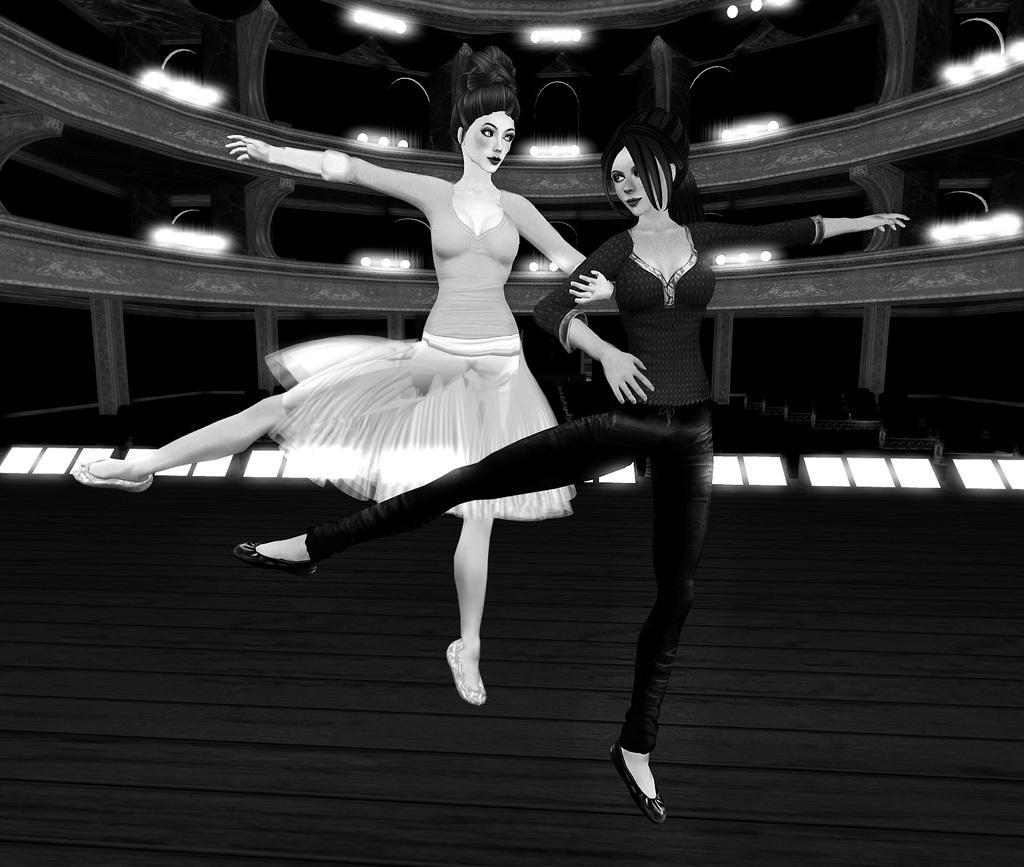How would you summarize this image in a sentence or two? In the picture we can see an animated image of two girls are dancing holding each other hands and behind them we can see the animated stadium building with seats and lights. 